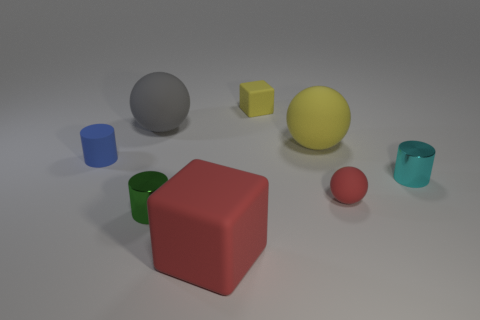Add 1 small green cylinders. How many objects exist? 9 Subtract all balls. How many objects are left? 5 Add 7 small rubber cubes. How many small rubber cubes are left? 8 Add 4 blue matte spheres. How many blue matte spheres exist? 4 Subtract 0 cyan balls. How many objects are left? 8 Subtract all yellow shiny blocks. Subtract all large yellow matte things. How many objects are left? 7 